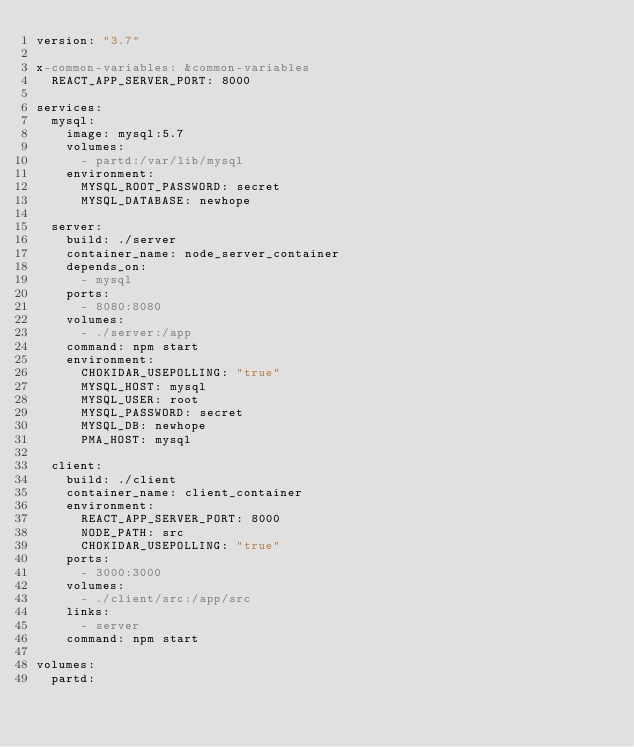<code> <loc_0><loc_0><loc_500><loc_500><_YAML_>version: "3.7"

x-common-variables: &common-variables
  REACT_APP_SERVER_PORT: 8000

services:
  mysql:
    image: mysql:5.7
    volumes:
      - partd:/var/lib/mysql
    environment:
      MYSQL_ROOT_PASSWORD: secret
      MYSQL_DATABASE: newhope
      
  server:
    build: ./server
    container_name: node_server_container
    depends_on:
      - mysql
    ports:
      - 8080:8080
    volumes:
      - ./server:/app
    command: npm start
    environment:
      CHOKIDAR_USEPOLLING: "true"
      MYSQL_HOST: mysql
      MYSQL_USER: root
      MYSQL_PASSWORD: secret
      MYSQL_DB: newhope
      PMA_HOST: mysql

  client:
    build: ./client
    container_name: client_container
    environment:
      REACT_APP_SERVER_PORT: 8000
      NODE_PATH: src
      CHOKIDAR_USEPOLLING: "true"
    ports:
      - 3000:3000
    volumes:
      - ./client/src:/app/src
    links:
      - server
    command: npm start

volumes:
  partd:</code> 